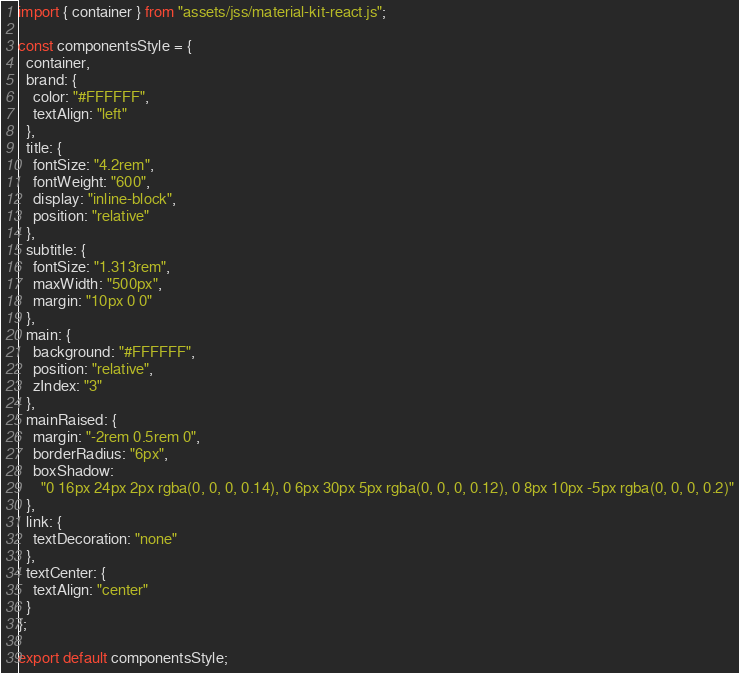Convert code to text. <code><loc_0><loc_0><loc_500><loc_500><_JavaScript_>import { container } from "assets/jss/material-kit-react.js";

const componentsStyle = {
  container,
  brand: {
    color: "#FFFFFF",
    textAlign: "left"
  },
  title: {
    fontSize: "4.2rem",
    fontWeight: "600",
    display: "inline-block",
    position: "relative"
  },
  subtitle: {
    fontSize: "1.313rem",
    maxWidth: "500px",
    margin: "10px 0 0"
  },
  main: {
    background: "#FFFFFF",
    position: "relative",
    zIndex: "3"
  },
  mainRaised: {
    margin: "-2rem 0.5rem 0",
    borderRadius: "6px",
    boxShadow:
      "0 16px 24px 2px rgba(0, 0, 0, 0.14), 0 6px 30px 5px rgba(0, 0, 0, 0.12), 0 8px 10px -5px rgba(0, 0, 0, 0.2)"
  },
  link: {
    textDecoration: "none"
  },
  textCenter: {
    textAlign: "center"
  }
};

export default componentsStyle;
</code> 